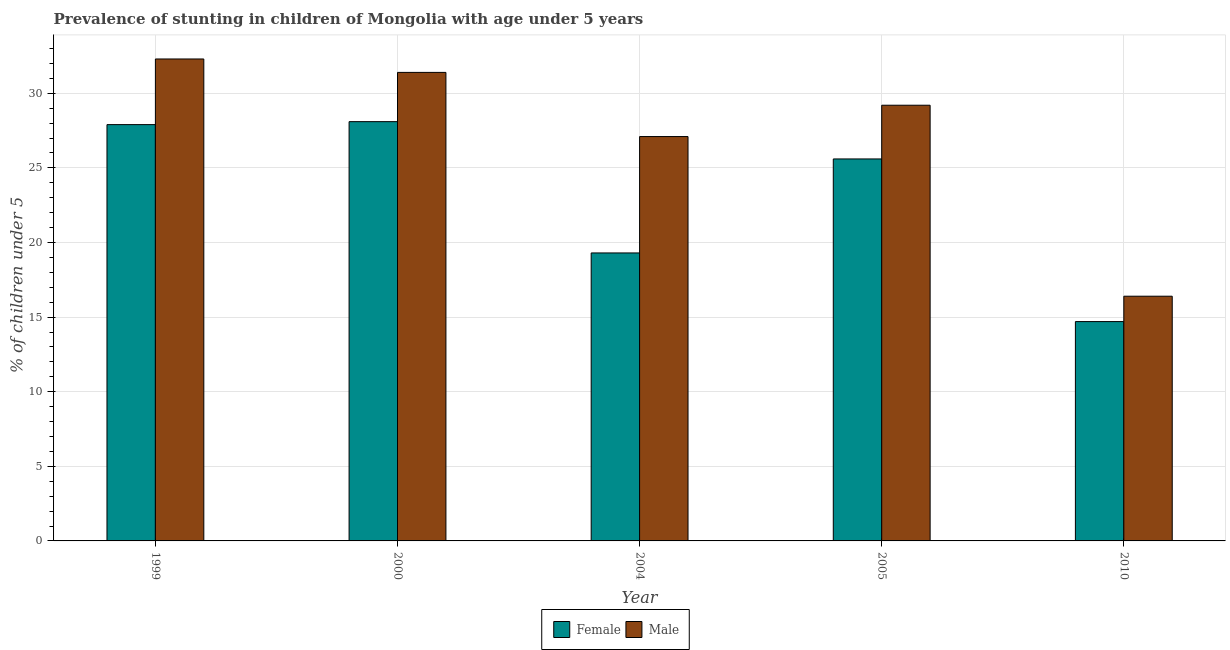Are the number of bars on each tick of the X-axis equal?
Your answer should be very brief. Yes. How many bars are there on the 3rd tick from the left?
Offer a terse response. 2. What is the label of the 3rd group of bars from the left?
Your answer should be compact. 2004. What is the percentage of stunted male children in 2010?
Ensure brevity in your answer.  16.4. Across all years, what is the maximum percentage of stunted female children?
Provide a succinct answer. 28.1. Across all years, what is the minimum percentage of stunted female children?
Make the answer very short. 14.7. In which year was the percentage of stunted female children maximum?
Provide a succinct answer. 2000. What is the total percentage of stunted female children in the graph?
Your answer should be very brief. 115.6. What is the difference between the percentage of stunted male children in 2000 and that in 2005?
Make the answer very short. 2.2. What is the difference between the percentage of stunted male children in 2010 and the percentage of stunted female children in 2004?
Offer a terse response. -10.7. What is the average percentage of stunted female children per year?
Keep it short and to the point. 23.12. In how many years, is the percentage of stunted female children greater than 9 %?
Keep it short and to the point. 5. What is the ratio of the percentage of stunted female children in 2000 to that in 2005?
Keep it short and to the point. 1.1. Is the difference between the percentage of stunted female children in 1999 and 2010 greater than the difference between the percentage of stunted male children in 1999 and 2010?
Provide a short and direct response. No. What is the difference between the highest and the second highest percentage of stunted male children?
Offer a terse response. 0.9. What is the difference between the highest and the lowest percentage of stunted male children?
Offer a terse response. 15.9. What does the 2nd bar from the left in 2005 represents?
Give a very brief answer. Male. What does the 2nd bar from the right in 2000 represents?
Your answer should be very brief. Female. What is the difference between two consecutive major ticks on the Y-axis?
Your answer should be very brief. 5. Does the graph contain grids?
Make the answer very short. Yes. How many legend labels are there?
Your response must be concise. 2. How are the legend labels stacked?
Offer a terse response. Horizontal. What is the title of the graph?
Ensure brevity in your answer.  Prevalence of stunting in children of Mongolia with age under 5 years. What is the label or title of the Y-axis?
Offer a very short reply.  % of children under 5. What is the  % of children under 5 of Female in 1999?
Your response must be concise. 27.9. What is the  % of children under 5 in Male in 1999?
Provide a short and direct response. 32.3. What is the  % of children under 5 in Female in 2000?
Ensure brevity in your answer.  28.1. What is the  % of children under 5 of Male in 2000?
Provide a succinct answer. 31.4. What is the  % of children under 5 of Female in 2004?
Your answer should be very brief. 19.3. What is the  % of children under 5 in Male in 2004?
Provide a short and direct response. 27.1. What is the  % of children under 5 in Female in 2005?
Ensure brevity in your answer.  25.6. What is the  % of children under 5 in Male in 2005?
Provide a short and direct response. 29.2. What is the  % of children under 5 of Female in 2010?
Provide a short and direct response. 14.7. What is the  % of children under 5 of Male in 2010?
Your response must be concise. 16.4. Across all years, what is the maximum  % of children under 5 of Female?
Your response must be concise. 28.1. Across all years, what is the maximum  % of children under 5 in Male?
Provide a short and direct response. 32.3. Across all years, what is the minimum  % of children under 5 of Female?
Your response must be concise. 14.7. Across all years, what is the minimum  % of children under 5 in Male?
Give a very brief answer. 16.4. What is the total  % of children under 5 in Female in the graph?
Offer a terse response. 115.6. What is the total  % of children under 5 of Male in the graph?
Your answer should be very brief. 136.4. What is the difference between the  % of children under 5 of Female in 1999 and that in 2000?
Keep it short and to the point. -0.2. What is the difference between the  % of children under 5 of Female in 1999 and that in 2004?
Make the answer very short. 8.6. What is the difference between the  % of children under 5 of Male in 1999 and that in 2004?
Offer a very short reply. 5.2. What is the difference between the  % of children under 5 in Male in 1999 and that in 2005?
Keep it short and to the point. 3.1. What is the difference between the  % of children under 5 of Female in 1999 and that in 2010?
Your response must be concise. 13.2. What is the difference between the  % of children under 5 of Male in 1999 and that in 2010?
Keep it short and to the point. 15.9. What is the difference between the  % of children under 5 of Female in 2000 and that in 2004?
Make the answer very short. 8.8. What is the difference between the  % of children under 5 of Male in 2000 and that in 2010?
Give a very brief answer. 15. What is the difference between the  % of children under 5 of Male in 2004 and that in 2005?
Keep it short and to the point. -2.1. What is the difference between the  % of children under 5 of Male in 2004 and that in 2010?
Provide a succinct answer. 10.7. What is the difference between the  % of children under 5 of Female in 2005 and that in 2010?
Provide a short and direct response. 10.9. What is the difference between the  % of children under 5 in Female in 1999 and the  % of children under 5 in Male in 2000?
Make the answer very short. -3.5. What is the difference between the  % of children under 5 of Female in 1999 and the  % of children under 5 of Male in 2004?
Your response must be concise. 0.8. What is the difference between the  % of children under 5 of Female in 2000 and the  % of children under 5 of Male in 2005?
Your answer should be very brief. -1.1. What is the difference between the  % of children under 5 in Female in 2004 and the  % of children under 5 in Male in 2010?
Provide a short and direct response. 2.9. What is the difference between the  % of children under 5 in Female in 2005 and the  % of children under 5 in Male in 2010?
Your answer should be very brief. 9.2. What is the average  % of children under 5 of Female per year?
Your answer should be compact. 23.12. What is the average  % of children under 5 in Male per year?
Your answer should be compact. 27.28. In the year 1999, what is the difference between the  % of children under 5 of Female and  % of children under 5 of Male?
Provide a succinct answer. -4.4. In the year 2000, what is the difference between the  % of children under 5 of Female and  % of children under 5 of Male?
Your answer should be very brief. -3.3. What is the ratio of the  % of children under 5 of Male in 1999 to that in 2000?
Make the answer very short. 1.03. What is the ratio of the  % of children under 5 of Female in 1999 to that in 2004?
Ensure brevity in your answer.  1.45. What is the ratio of the  % of children under 5 in Male in 1999 to that in 2004?
Give a very brief answer. 1.19. What is the ratio of the  % of children under 5 in Female in 1999 to that in 2005?
Make the answer very short. 1.09. What is the ratio of the  % of children under 5 of Male in 1999 to that in 2005?
Provide a short and direct response. 1.11. What is the ratio of the  % of children under 5 in Female in 1999 to that in 2010?
Offer a terse response. 1.9. What is the ratio of the  % of children under 5 of Male in 1999 to that in 2010?
Give a very brief answer. 1.97. What is the ratio of the  % of children under 5 in Female in 2000 to that in 2004?
Offer a very short reply. 1.46. What is the ratio of the  % of children under 5 of Male in 2000 to that in 2004?
Your answer should be very brief. 1.16. What is the ratio of the  % of children under 5 of Female in 2000 to that in 2005?
Offer a very short reply. 1.1. What is the ratio of the  % of children under 5 of Male in 2000 to that in 2005?
Make the answer very short. 1.08. What is the ratio of the  % of children under 5 in Female in 2000 to that in 2010?
Give a very brief answer. 1.91. What is the ratio of the  % of children under 5 in Male in 2000 to that in 2010?
Offer a very short reply. 1.91. What is the ratio of the  % of children under 5 of Female in 2004 to that in 2005?
Keep it short and to the point. 0.75. What is the ratio of the  % of children under 5 in Male in 2004 to that in 2005?
Your response must be concise. 0.93. What is the ratio of the  % of children under 5 of Female in 2004 to that in 2010?
Provide a short and direct response. 1.31. What is the ratio of the  % of children under 5 of Male in 2004 to that in 2010?
Make the answer very short. 1.65. What is the ratio of the  % of children under 5 of Female in 2005 to that in 2010?
Your response must be concise. 1.74. What is the ratio of the  % of children under 5 in Male in 2005 to that in 2010?
Provide a succinct answer. 1.78. What is the difference between the highest and the second highest  % of children under 5 in Female?
Provide a short and direct response. 0.2. What is the difference between the highest and the lowest  % of children under 5 in Male?
Offer a terse response. 15.9. 